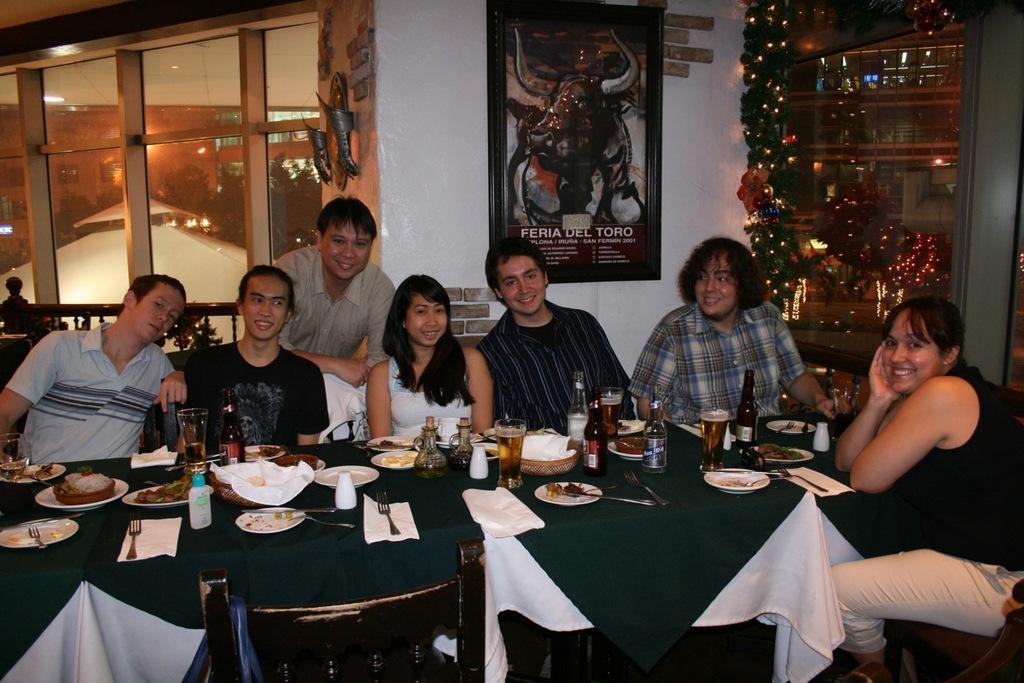In one or two sentences, can you explain what this image depicts? In this image, we can see a group of people. Few people are sitting. Here there is a table cover with cloth. So many things and items are placed on it. At the bottom, we can see chair. Background we can see wall, railing, poster, decorative objects, glass things. Here a person is standing. Through the glasses, we can see outside views. Here we can see buildings and trees. 